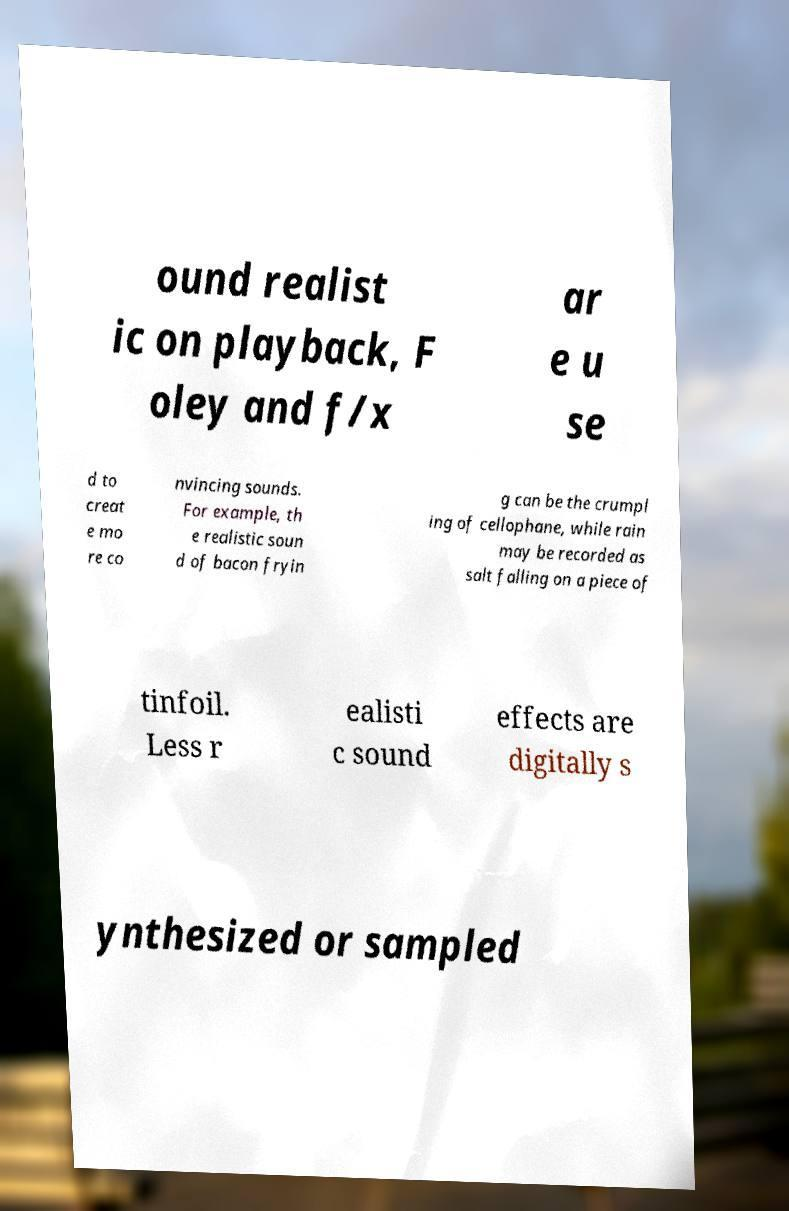Please identify and transcribe the text found in this image. ound realist ic on playback, F oley and f/x ar e u se d to creat e mo re co nvincing sounds. For example, th e realistic soun d of bacon fryin g can be the crumpl ing of cellophane, while rain may be recorded as salt falling on a piece of tinfoil. Less r ealisti c sound effects are digitally s ynthesized or sampled 